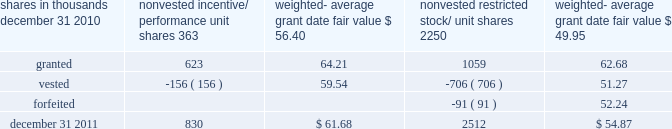There were no options granted in excess of market value in 2011 , 2010 or 2009 .
Shares of common stock available during the next year for the granting of options and other awards under the incentive plans were 33775543 at december 31 , 2011 .
Total shares of pnc common stock authorized for future issuance under equity compensation plans totaled 35304422 shares at december 31 , 2011 , which includes shares available for issuance under the incentive plans and the employee stock purchase plan ( espp ) as described below .
During 2011 , we issued 731336 shares from treasury stock in connection with stock option exercise activity .
As with past exercise activity , we currently intend to utilize primarily treasury stock for any future stock option exercises .
Awards granted to non-employee directors in 2011 , 2010 and 2009 include 27090 , 29040 , and 39552 deferred stock units , respectively , awarded under the outside directors deferred stock unit plan .
A deferred stock unit is a phantom share of our common stock , which requires liability accounting treatment until such awards are paid to the participants as cash .
As there are no vesting or service requirements on these awards , total compensation expense is recognized in full on awarded deferred stock units on the date of grant .
Incentive/performance unit share awards and restricted stock/unit awards the fair value of nonvested incentive/performance unit share awards and restricted stock/unit awards is initially determined based on prices not less than the market value of our common stock price on the date of grant .
The value of certain incentive/ performance unit share awards is subsequently remeasured based on the achievement of one or more financial and other performance goals generally over a three-year period .
The personnel and compensation committee of the board of directors approves the final award payout with respect to incentive/performance unit share awards .
Restricted stock/unit awards have various vesting periods generally ranging from 36 months to 60 months .
Beginning in 2011 , we incorporated two changes to certain awards under our existing long-term incentive compensation programs .
First , for certain grants of incentive performance units , the future payout amount will be subject to a negative annual adjustment if pnc fails to meet certain risk-related performance metrics .
This adjustment is in addition to the existing financial performance metrics relative to our peers .
These grants have a three-year performance period and are payable in either stock or a combination of stock and cash .
Second , performance-based restricted share units ( performance rsus ) were granted in 2011 to certain of our executives in lieu of stock options .
These performance rsus ( which are payable solely in stock ) have a service condition , an internal risk-related performance condition , and an external market condition .
Satisfaction of the performance condition is based on four independent one-year performance periods .
The weighted-average grant-date fair value of incentive/ performance unit share awards and restricted stock/unit awards granted in 2011 , 2010 and 2009 was $ 63.25 , $ 54.59 and $ 41.16 per share , respectively .
We recognize compensation expense for such awards ratably over the corresponding vesting and/or performance periods for each type of program .
Nonvested incentive/performance unit share awards and restricted stock/unit awards 2013 rollforward shares in thousands nonvested incentive/ performance unit shares weighted- average date fair nonvested restricted stock/ shares weighted- average date fair .
In the chart above , the unit shares and related weighted- average grant-date fair value of the incentive/performance awards exclude the effect of dividends on the underlying shares , as those dividends will be paid in cash .
At december 31 , 2011 , there was $ 61 million of unrecognized deferred compensation expense related to nonvested share- based compensation arrangements granted under the incentive plans .
This cost is expected to be recognized as expense over a period of no longer than five years .
The total fair value of incentive/performance unit share and restricted stock/unit awards vested during 2011 , 2010 and 2009 was approximately $ 52 million , $ 39 million and $ 47 million , respectively .
Liability awards we grant annually cash-payable restricted share units to certain executives .
The grants were made primarily as part of an annual bonus incentive deferral plan .
While there are time- based and service-related vesting criteria , there are no market or performance criteria associated with these awards .
Compensation expense recognized related to these awards was recorded in prior periods as part of annual cash bonus criteria .
As of december 31 , 2011 , there were 753203 of these cash- payable restricted share units outstanding .
174 the pnc financial services group , inc .
2013 form 10-k .
As of december 31 2011 , what were total non-vest iso's and restricted share units , in thousands? 
Computations: (830 + 2512)
Answer: 3342.0. 